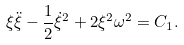Convert formula to latex. <formula><loc_0><loc_0><loc_500><loc_500>\xi \ddot { \xi } - \frac { 1 } { 2 } \dot { \xi } ^ { 2 } + 2 \xi ^ { 2 } \omega ^ { 2 } = C _ { 1 } .</formula> 